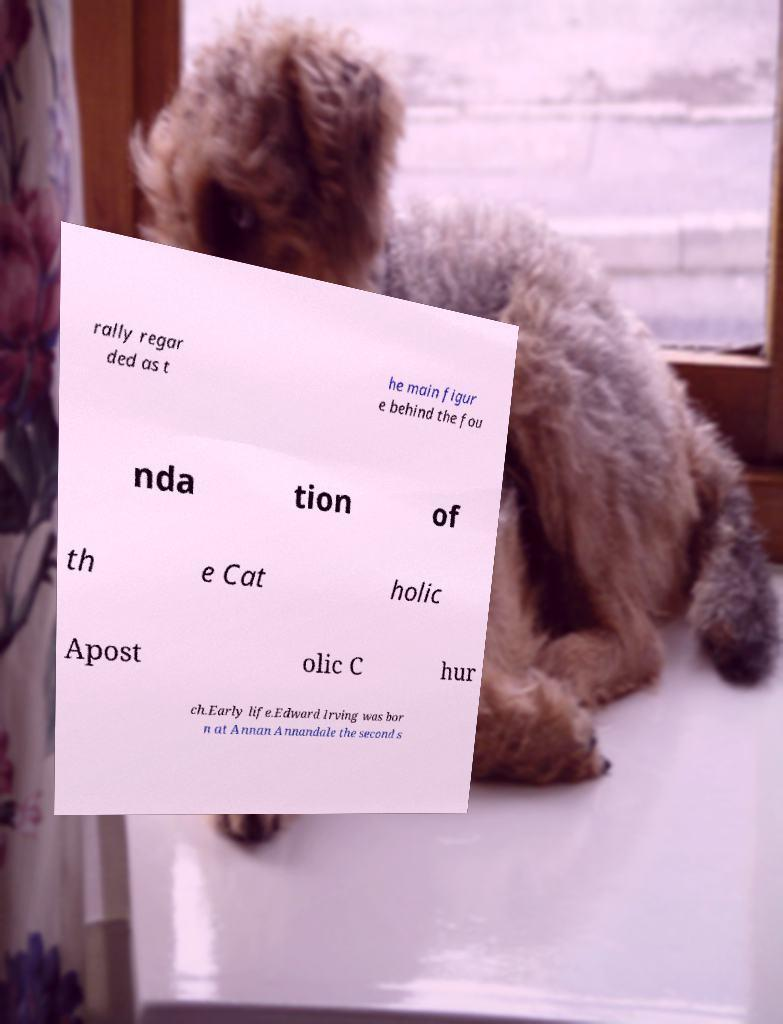There's text embedded in this image that I need extracted. Can you transcribe it verbatim? rally regar ded as t he main figur e behind the fou nda tion of th e Cat holic Apost olic C hur ch.Early life.Edward Irving was bor n at Annan Annandale the second s 